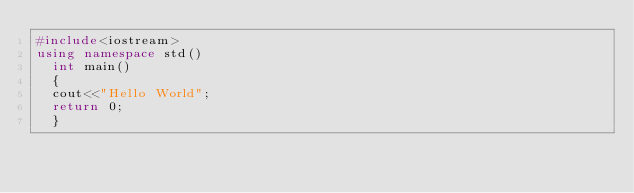<code> <loc_0><loc_0><loc_500><loc_500><_C++_>#include<iostream>
using namespace std()
  int main()
  {
  cout<<"Hello World";
  return 0;
  }
</code> 